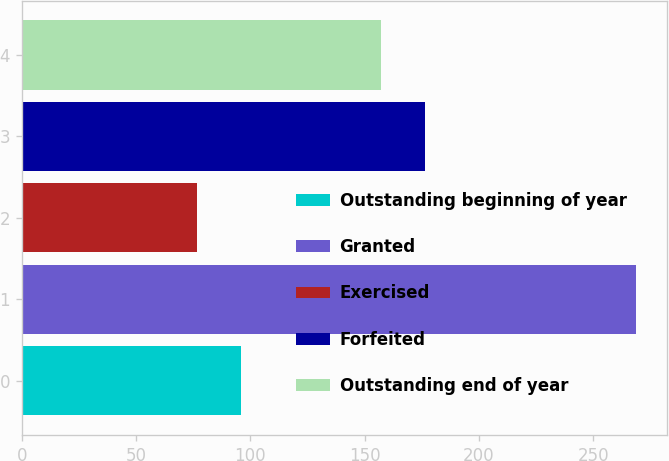Convert chart. <chart><loc_0><loc_0><loc_500><loc_500><bar_chart><fcel>Outstanding beginning of year<fcel>Granted<fcel>Exercised<fcel>Forfeited<fcel>Outstanding end of year<nl><fcel>95.98<fcel>268.73<fcel>76.78<fcel>176.26<fcel>157.07<nl></chart> 